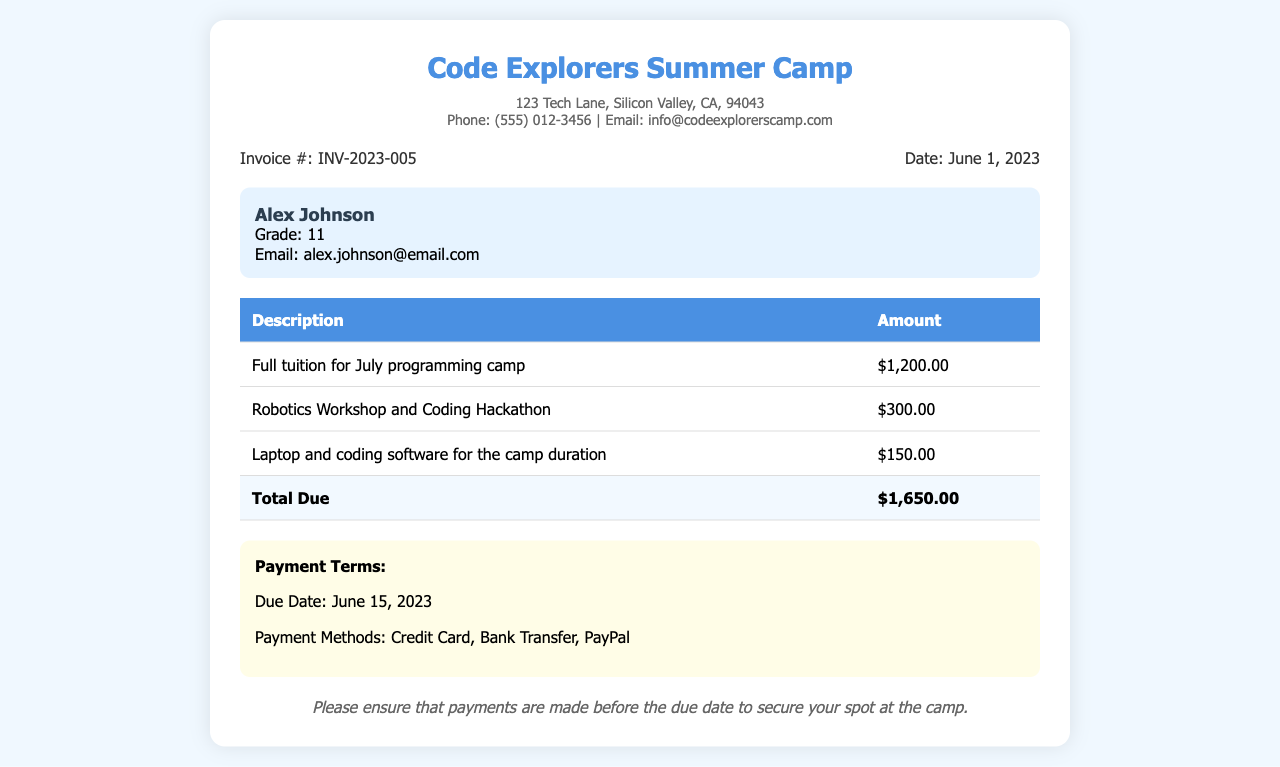what is the name of the camp? The name of the camp is found in the title section of the document.
Answer: Code Explorers Summer Camp who is the student associated with this invoice? The student's name is provided in the student information section of the document.
Answer: Alex Johnson what is the total amount due? The total due is calculated and displayed in the total row of the invoice.
Answer: $1,650.00 when is the payment due? The due date for payment is specified in the payment terms section of the document.
Answer: June 15, 2023 how much is the tuition for the programming camp? The tuition amount is listed in the table under the description of full tuition.
Answer: $1,200.00 what additional activity is included apart from tuition? The invoice includes a robotics workshop and coding hackathon as an additional activity.
Answer: Robotics Workshop and Coding Hackathon what payment methods are accepted? The accepted payment methods are outlined in the payment terms section of the document.
Answer: Credit Card, Bank Transfer, PayPal how much is charged for equipment rental? The charge for equipment rental is found in the table alongside its description.
Answer: $150.00 